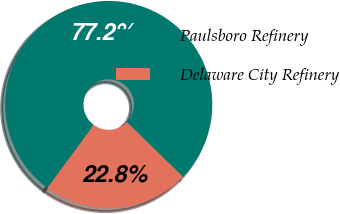<chart> <loc_0><loc_0><loc_500><loc_500><pie_chart><fcel>Paulsboro Refinery<fcel>Delaware City Refinery<nl><fcel>77.19%<fcel>22.81%<nl></chart> 